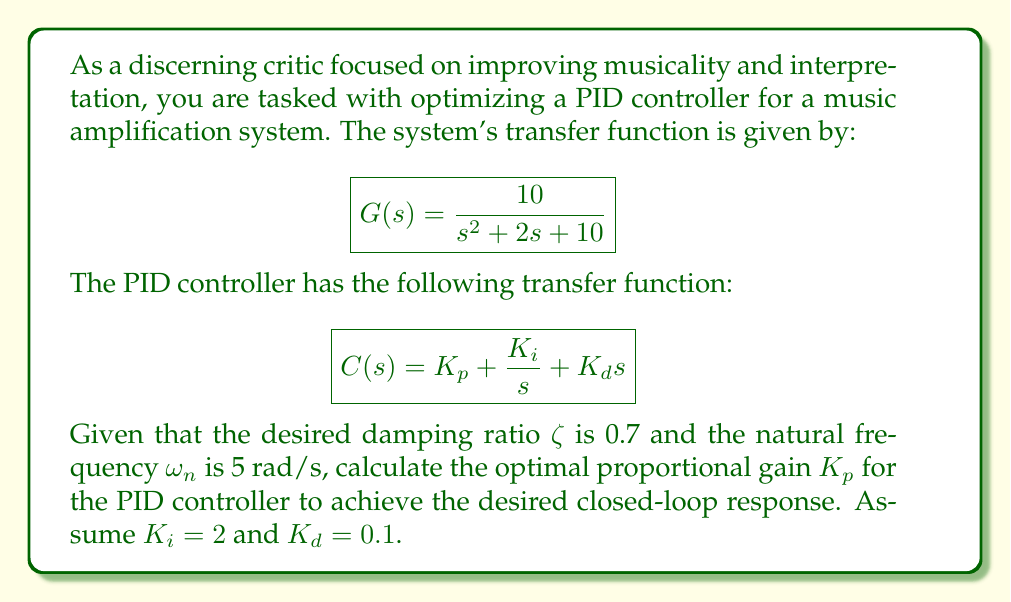Solve this math problem. To solve this problem, we'll follow these steps:

1) The closed-loop transfer function of the system with the PID controller is:

   $$T(s) = \frac{C(s)G(s)}{1 + C(s)G(s)}$$

2) Substituting the given transfer functions:

   $$T(s) = \frac{(K_p + \frac{K_i}{s} + K_d s) \cdot \frac{10}{s^2 + 2s + 10}}{1 + (K_p + \frac{K_i}{s} + K_d s) \cdot \frac{10}{s^2 + 2s + 10}}$$

3) The characteristic equation of this closed-loop system is:

   $$s^2 + 2s + 10 + 10K_p + \frac{10K_i}{s} + 10K_d s = 0$$

4) Multiplying both sides by s:

   $$s^3 + 2s^2 + 10s + 10K_p s + 10K_i + 10K_d s^2 = 0$$

5) Rearranging:

   $$s^3 + (2 + 10K_d)s^2 + (10 + 10K_p)s + 10K_i = 0$$

6) The desired characteristic equation for a second-order system with damping ratio ζ and natural frequency ω_n is:

   $$s^2 + 2ζω_n s + ω_n^2 = 0$$

7) For our third-order system to approximate this behavior, we want:

   $$(2 + 10K_d) = 2ζω_n$$
   $$(10 + 10K_p) = ω_n^2$$
   $$10K_i$$ should be small

8) From the second equation:

   $$10 + 10K_p = ω_n^2 = 5^2 = 25$$

9) Solving for K_p:

   $$K_p = \frac{25 - 10}{10} = 1.5$$

This value of K_p should provide the desired closed-loop response characteristics.
Answer: $K_p = 1.5$ 